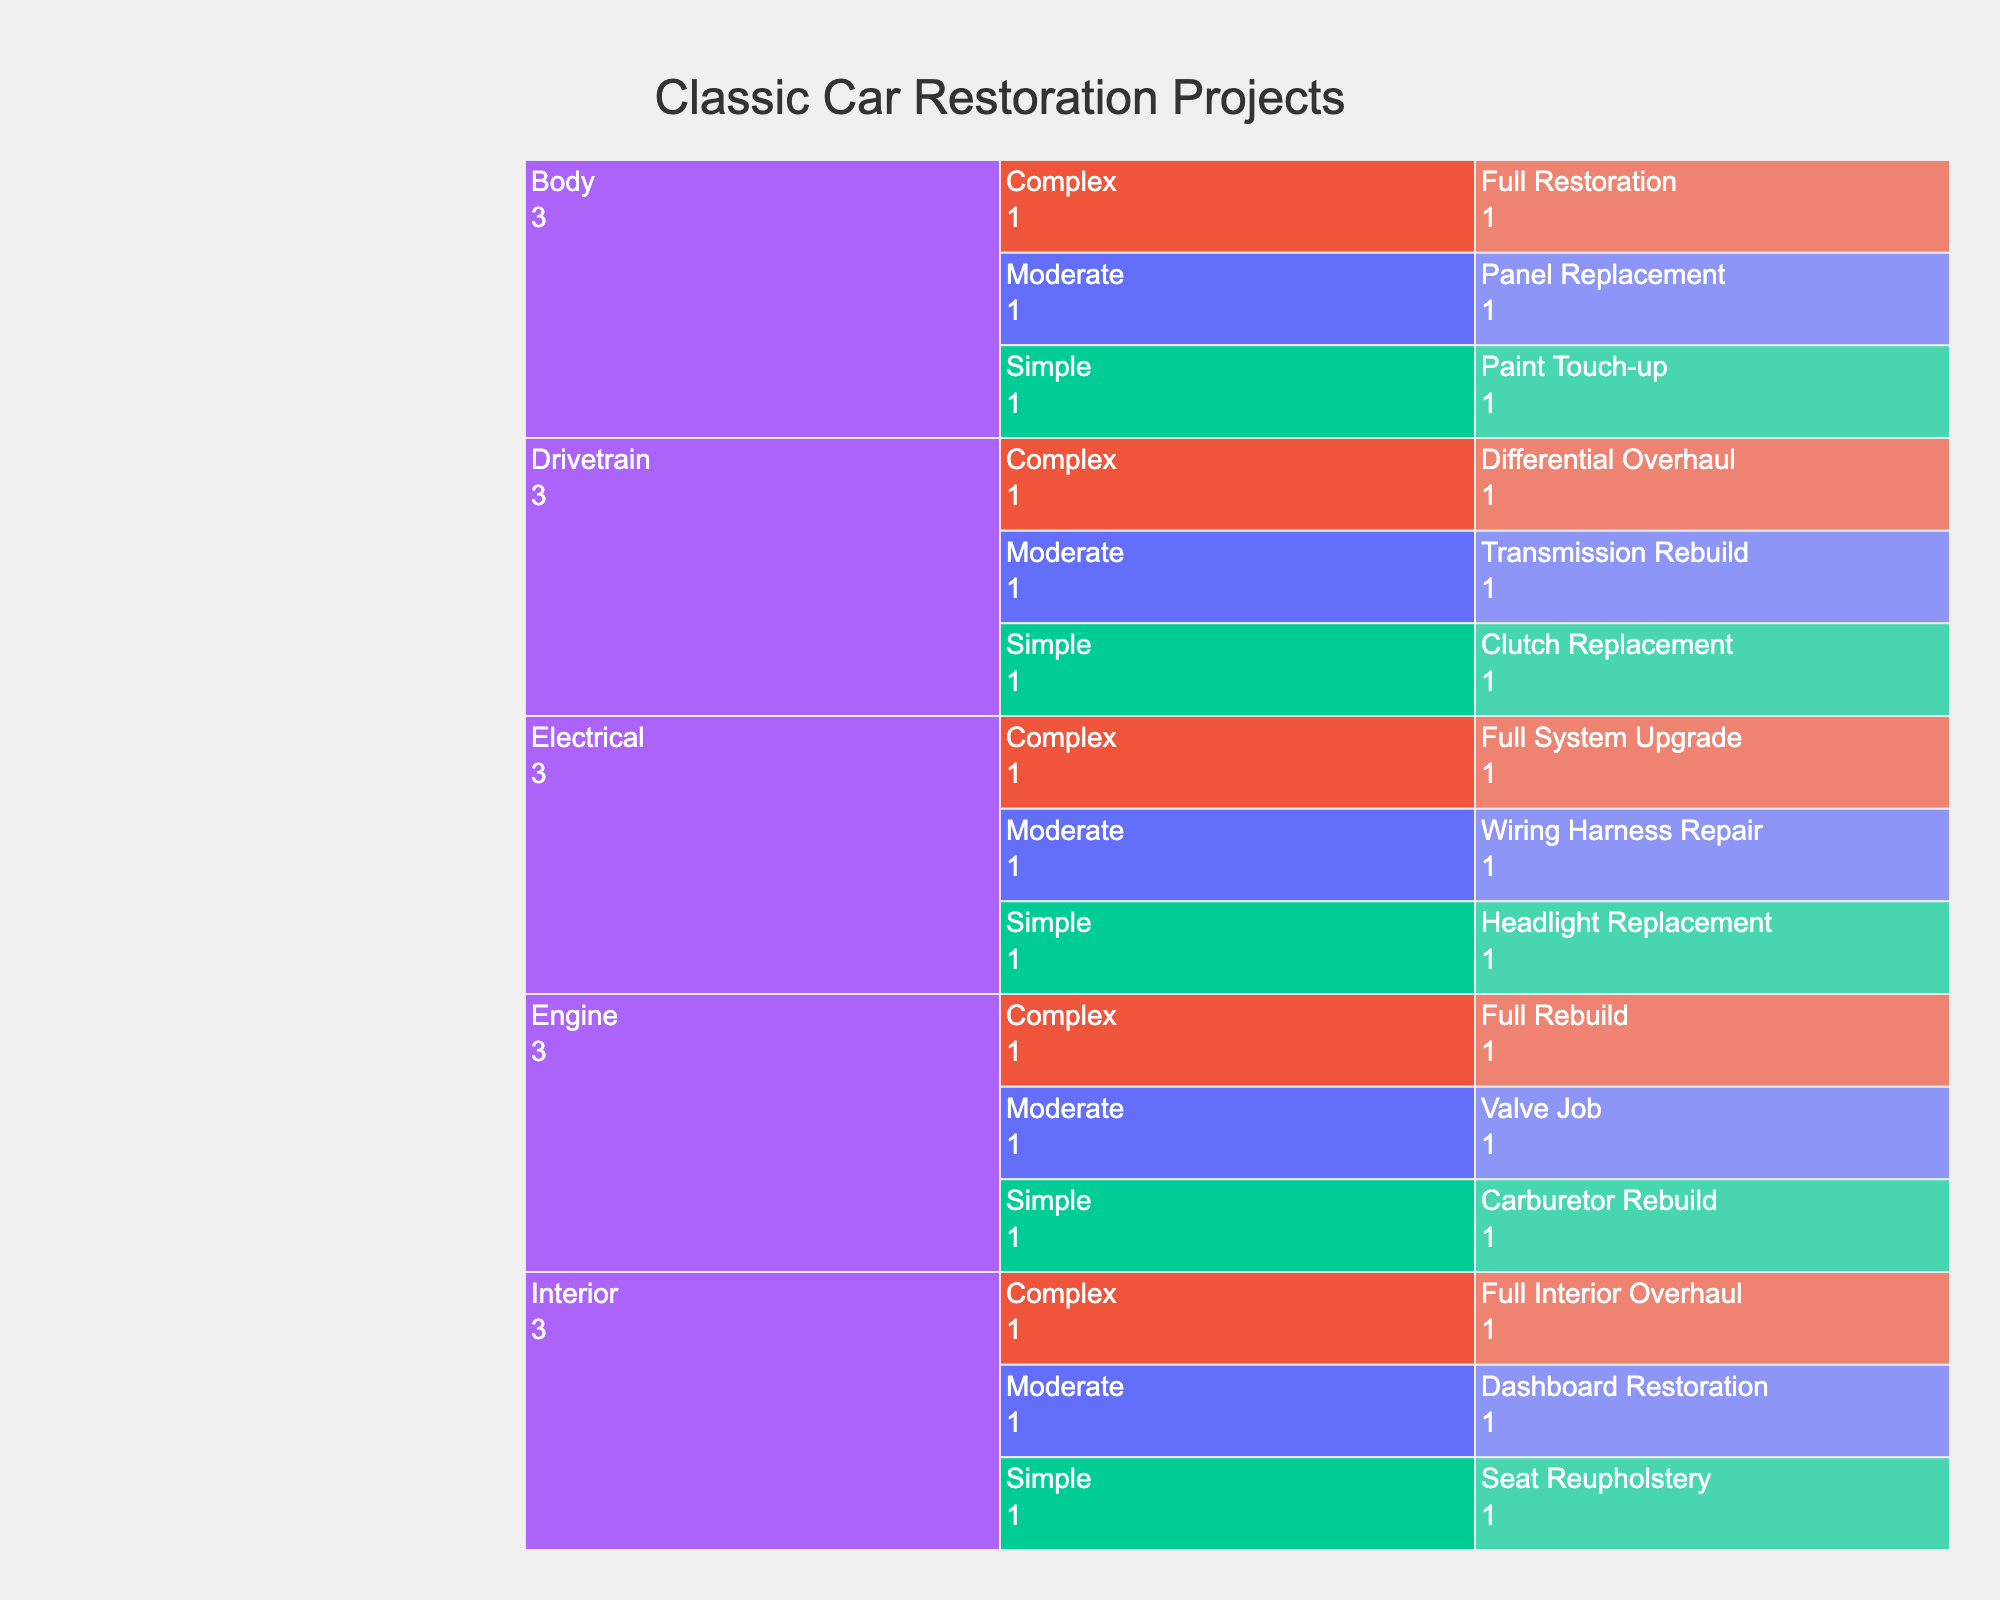What is the title of the icicle chart? The title appears at the top of the chart. It is a basic visual feature that describes what the chart represents.
Answer: Classic Car Restoration Projects How many categories of car restoration projects are there in the chart? To find the number of categories, look at the first level of the icicle chart which represents the major categories. Count these categories.
Answer: 5 Which subcategory in the Engine category has the highest difficulty level? Navigate the Engine category down to its subcategories and compare the difficulty levels of each subcategory. The subcategory with "High" difficulty is the one with the highest difficulty.
Answer: Full Rebuild What are the required skills for a complex body restoration project? Look at the Body category and then at the "Complex" subcategory under Body. Check the hover data for "Required Skills."
Answer: Advanced Bodywork and Painting Which subcategory has the lowest parts availability in the Electrical category? Navigate to the Electrical category, then compare the "Parts Availability" for each subcategory. The one marked "Low" has the lowest parts availability.
Answer: Full System Upgrade Compare the difficulty levels of Simple and Moderate projects in the Drivetrain category. Which one is higher? Look at the Drivetrain category and compare the difficulty levels of Simple and Moderate projects.
Answer: Moderate What is the parts availability for a Full Interior Overhaul project? Navigate to the Interior category, specifically to the "Complex" subcategory for Full Interior Overhaul, and check the parts availability.
Answer: Low Which category has the most projects listed in the chart? Count the number of projects under each category in the icicle chart and identify the category with the highest count.
Answer: Engine What is the required skill level for a Valve Job project in the Engine category? Navigate to the Engine category and look for the "Valve Job" project. Check the hover data for "Required Skills."
Answer: Intermediate Mechanical Compare the parts availability for a Dashboard Restoration and Full Interior Overhaul. Which project has higher parts availability? Navigate to the Interior category and examine the subcategories for Dashboard Restoration (Moderate) and Full Interior Overhaul (Complex). Compare their parts availability.
Answer: Dashboard Restoration 